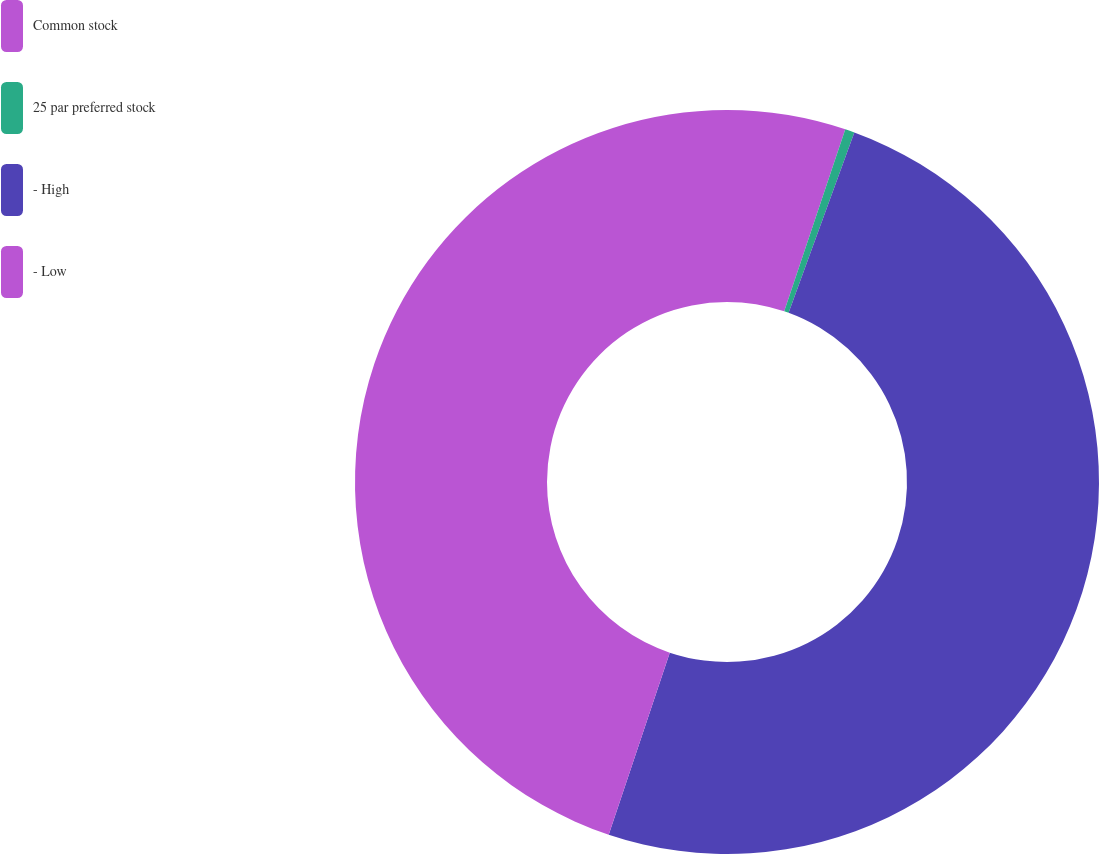<chart> <loc_0><loc_0><loc_500><loc_500><pie_chart><fcel>Common stock<fcel>25 par preferred stock<fcel>- High<fcel>- Low<nl><fcel>5.15%<fcel>0.41%<fcel>49.59%<fcel>44.85%<nl></chart> 